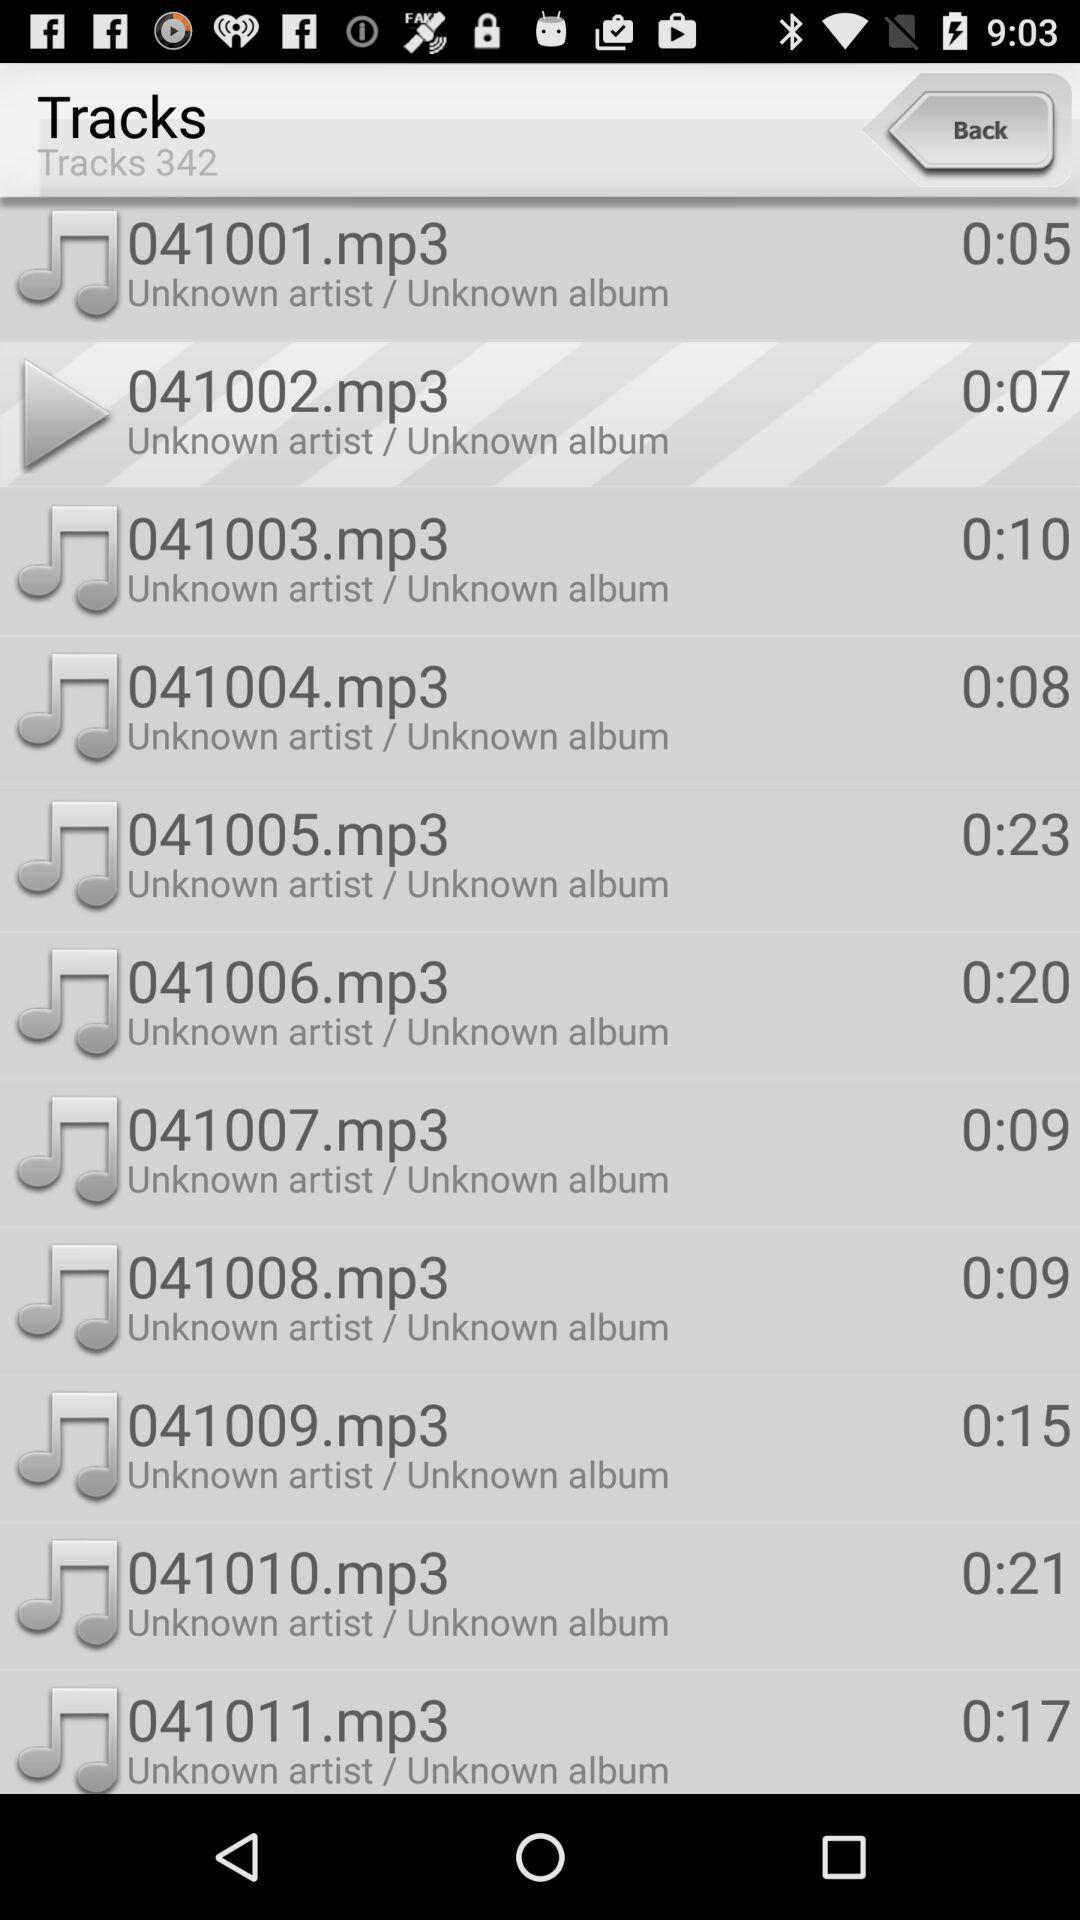How many tracks in total are there? There are 342 tracks. 